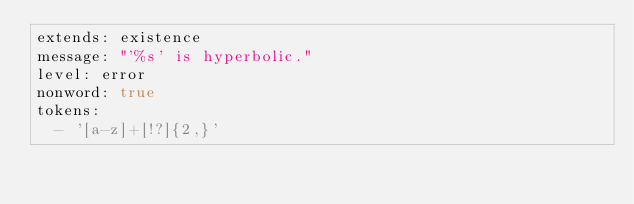<code> <loc_0><loc_0><loc_500><loc_500><_YAML_>extends: existence
message: "'%s' is hyperbolic."
level: error
nonword: true
tokens:
  - '[a-z]+[!?]{2,}'
</code> 